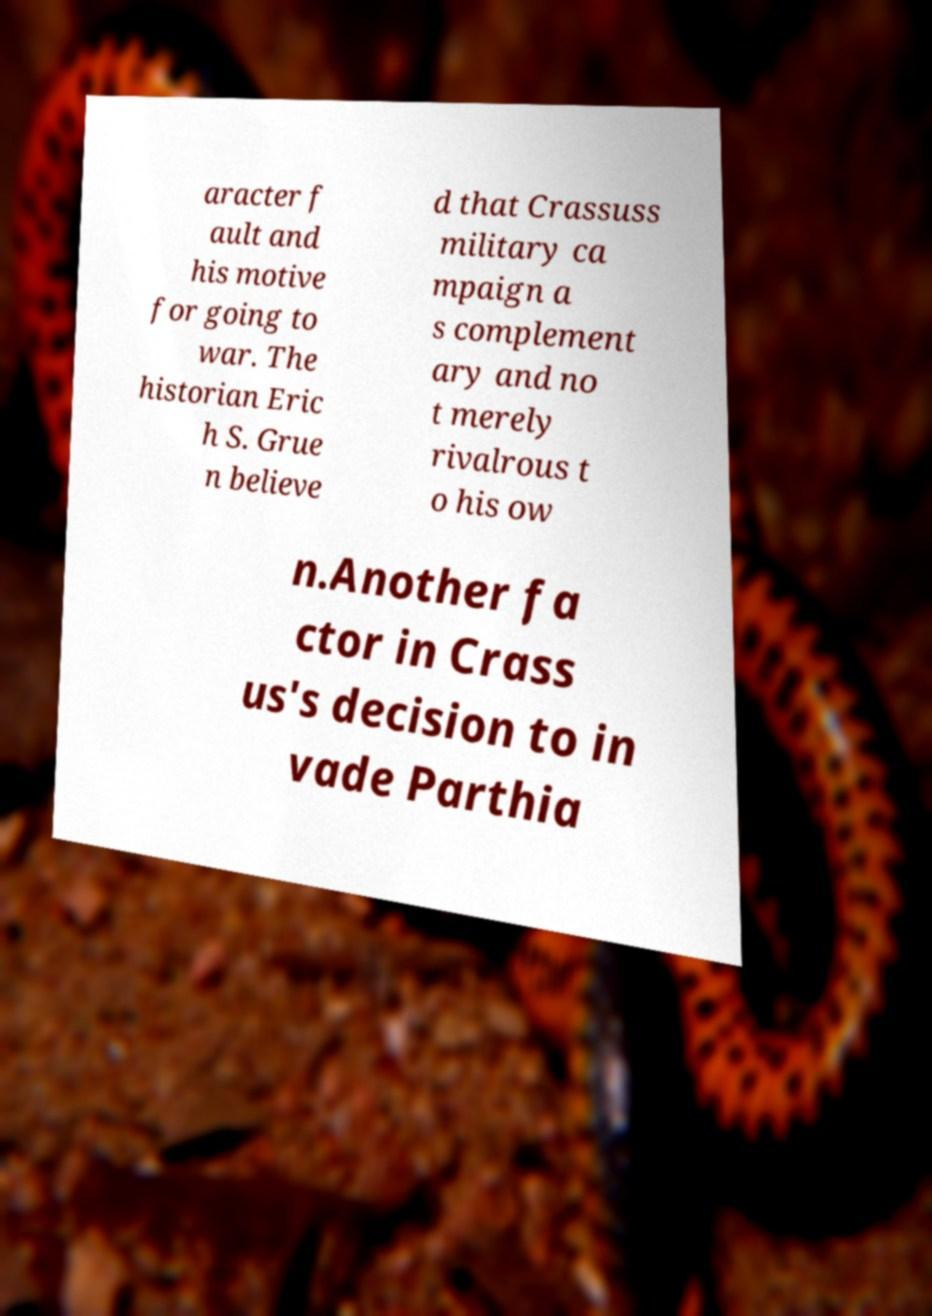I need the written content from this picture converted into text. Can you do that? aracter f ault and his motive for going to war. The historian Eric h S. Grue n believe d that Crassuss military ca mpaign a s complement ary and no t merely rivalrous t o his ow n.Another fa ctor in Crass us's decision to in vade Parthia 